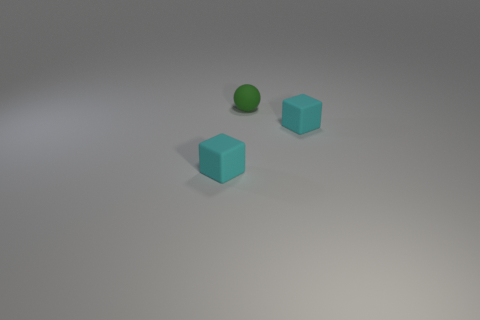Is there an object that is to the right of the small cyan matte block to the left of the ball? Yes, there is a slightly larger cyan block positioned to the right of the smaller cyan matte block, which itself is situated to the left of the green ball. 